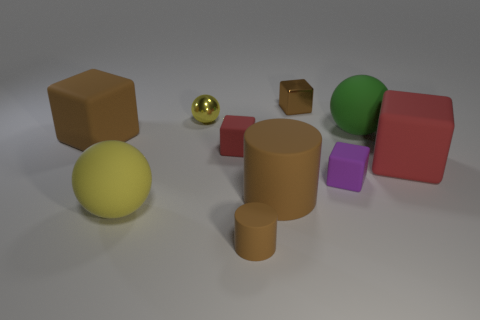Does the matte ball right of the purple matte object have the same size as the yellow ball in front of the tiny yellow shiny sphere?
Your response must be concise. Yes. There is a object that is left of the tiny metallic cube and to the right of the small cylinder; what material is it?
Provide a succinct answer. Rubber. There is another rubber cylinder that is the same color as the small cylinder; what is its size?
Your answer should be very brief. Large. What number of other objects are there of the same size as the yellow matte object?
Give a very brief answer. 4. What is the material of the tiny brown cylinder that is in front of the tiny red rubber thing?
Provide a short and direct response. Rubber. Do the tiny red matte thing and the big red object have the same shape?
Provide a short and direct response. Yes. How many other things are the same shape as the tiny yellow object?
Offer a very short reply. 2. What is the color of the small shiny block behind the green rubber thing?
Your response must be concise. Brown. Do the green rubber ball and the purple matte cube have the same size?
Your response must be concise. No. There is a block left of the ball that is in front of the large matte cylinder; what is its material?
Keep it short and to the point. Rubber. 